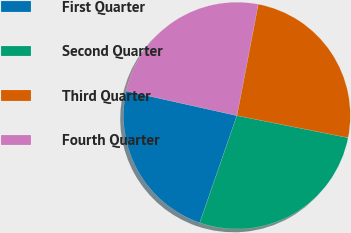<chart> <loc_0><loc_0><loc_500><loc_500><pie_chart><fcel>First Quarter<fcel>Second Quarter<fcel>Third Quarter<fcel>Fourth Quarter<nl><fcel>23.18%<fcel>27.19%<fcel>25.11%<fcel>24.52%<nl></chart> 